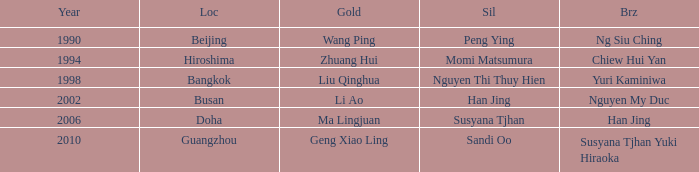What Gold has the Year of 1994? Zhuang Hui. 